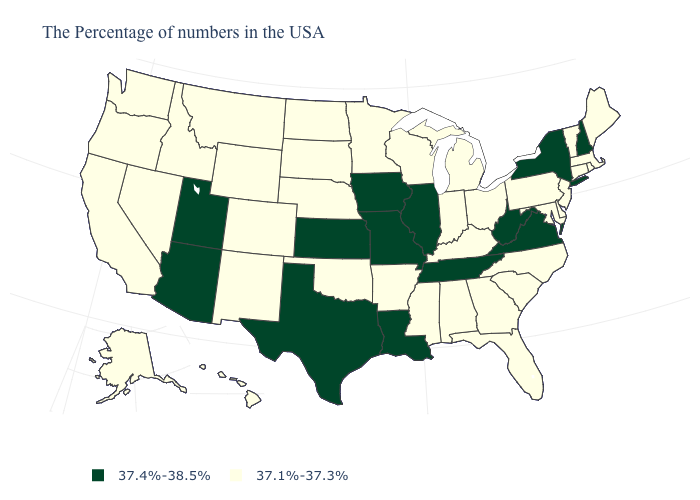What is the value of Washington?
Answer briefly. 37.1%-37.3%. Which states hav the highest value in the MidWest?
Keep it brief. Illinois, Missouri, Iowa, Kansas. What is the value of Florida?
Quick response, please. 37.1%-37.3%. What is the lowest value in the USA?
Write a very short answer. 37.1%-37.3%. Which states hav the highest value in the West?
Give a very brief answer. Utah, Arizona. What is the lowest value in the USA?
Give a very brief answer. 37.1%-37.3%. What is the value of Minnesota?
Answer briefly. 37.1%-37.3%. What is the value of Vermont?
Quick response, please. 37.1%-37.3%. What is the highest value in the MidWest ?
Keep it brief. 37.4%-38.5%. What is the value of New Jersey?
Concise answer only. 37.1%-37.3%. Name the states that have a value in the range 37.4%-38.5%?
Answer briefly. New Hampshire, New York, Virginia, West Virginia, Tennessee, Illinois, Louisiana, Missouri, Iowa, Kansas, Texas, Utah, Arizona. How many symbols are there in the legend?
Keep it brief. 2. What is the highest value in the MidWest ?
Write a very short answer. 37.4%-38.5%. Name the states that have a value in the range 37.1%-37.3%?
Keep it brief. Maine, Massachusetts, Rhode Island, Vermont, Connecticut, New Jersey, Delaware, Maryland, Pennsylvania, North Carolina, South Carolina, Ohio, Florida, Georgia, Michigan, Kentucky, Indiana, Alabama, Wisconsin, Mississippi, Arkansas, Minnesota, Nebraska, Oklahoma, South Dakota, North Dakota, Wyoming, Colorado, New Mexico, Montana, Idaho, Nevada, California, Washington, Oregon, Alaska, Hawaii. Name the states that have a value in the range 37.1%-37.3%?
Quick response, please. Maine, Massachusetts, Rhode Island, Vermont, Connecticut, New Jersey, Delaware, Maryland, Pennsylvania, North Carolina, South Carolina, Ohio, Florida, Georgia, Michigan, Kentucky, Indiana, Alabama, Wisconsin, Mississippi, Arkansas, Minnesota, Nebraska, Oklahoma, South Dakota, North Dakota, Wyoming, Colorado, New Mexico, Montana, Idaho, Nevada, California, Washington, Oregon, Alaska, Hawaii. 